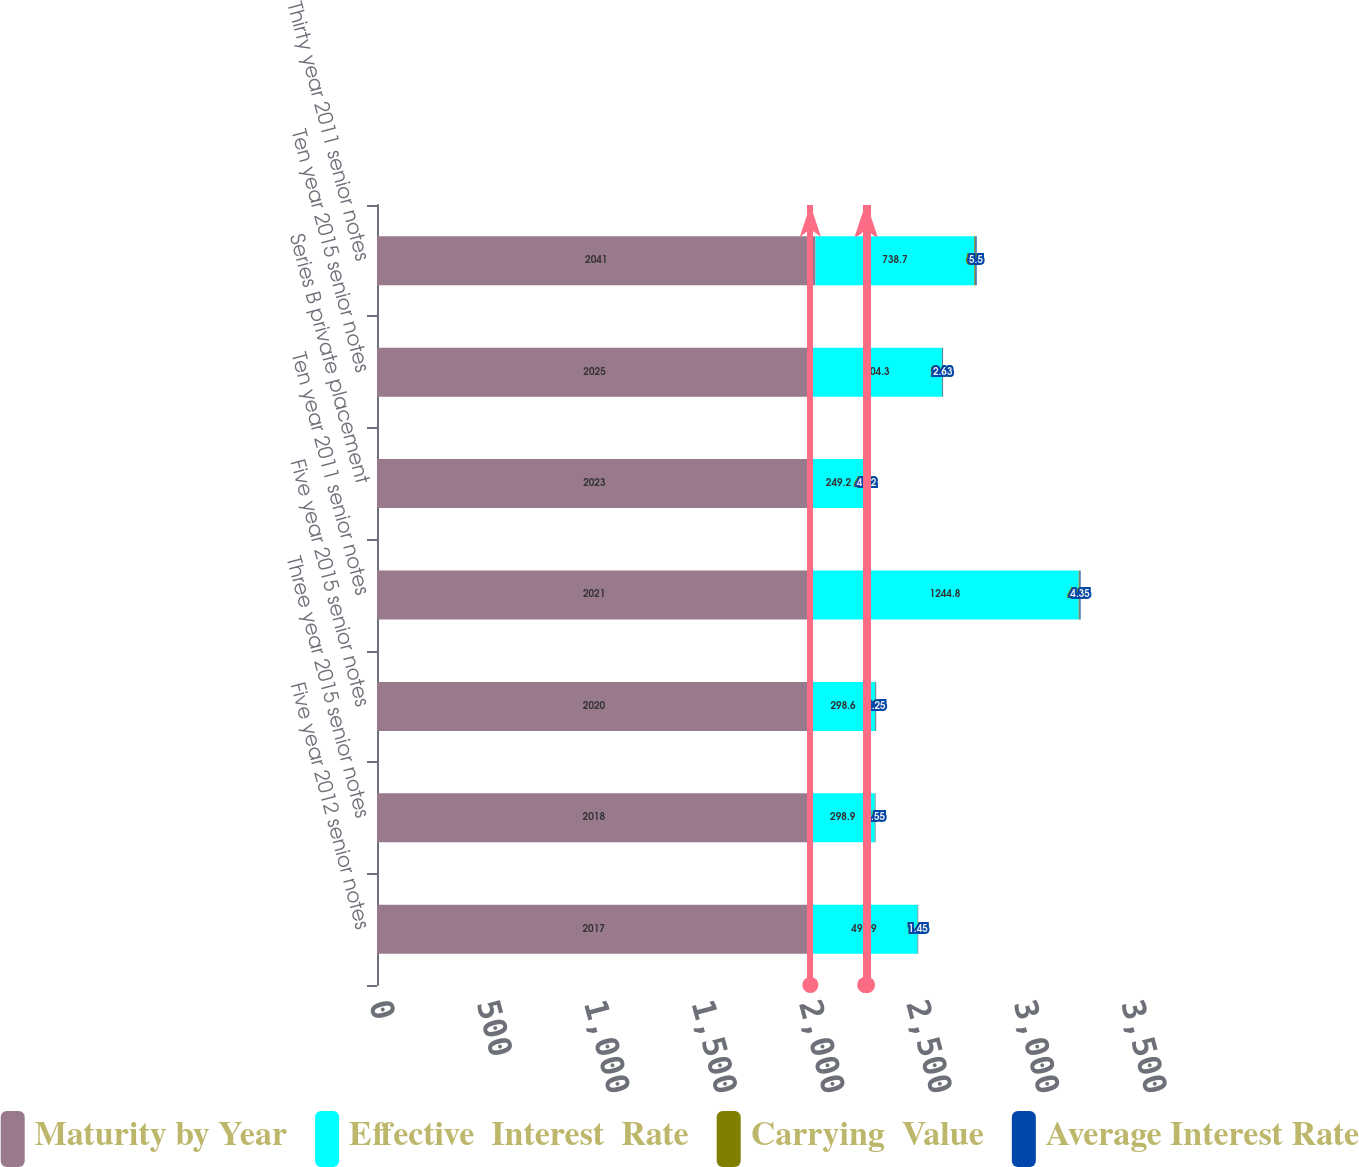<chart> <loc_0><loc_0><loc_500><loc_500><stacked_bar_chart><ecel><fcel>Five year 2012 senior notes<fcel>Three year 2015 senior notes<fcel>Five year 2015 senior notes<fcel>Ten year 2011 senior notes<fcel>Series B private placement<fcel>Ten year 2015 senior notes<fcel>Thirty year 2011 senior notes<nl><fcel>Maturity by Year<fcel>2017<fcel>2018<fcel>2020<fcel>2021<fcel>2023<fcel>2025<fcel>2041<nl><fcel>Effective  Interest  Rate<fcel>498.9<fcel>298.9<fcel>298.6<fcel>1244.8<fcel>249.2<fcel>604.3<fcel>738.7<nl><fcel>Carrying  Value<fcel>1.45<fcel>1.55<fcel>2.25<fcel>4.35<fcel>4.32<fcel>2.63<fcel>5.5<nl><fcel>Average Interest Rate<fcel>1.45<fcel>1.55<fcel>2.25<fcel>4.35<fcel>4.32<fcel>2.63<fcel>5.5<nl></chart> 